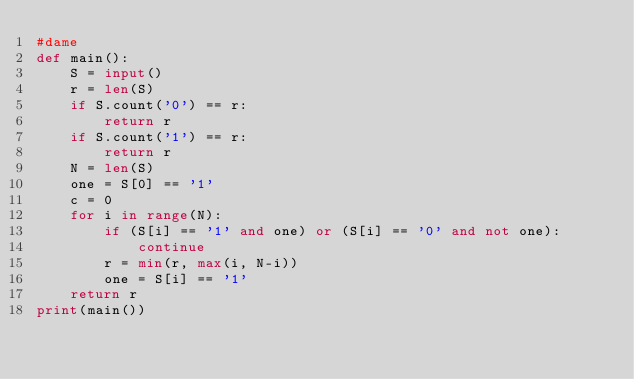<code> <loc_0><loc_0><loc_500><loc_500><_Python_>#dame 
def main():
    S = input()
    r = len(S)
    if S.count('0') == r:
        return r
    if S.count('1') == r:
        return r
    N = len(S)
    one = S[0] == '1'
    c = 0
    for i in range(N):
        if (S[i] == '1' and one) or (S[i] == '0' and not one):
            continue
        r = min(r, max(i, N-i))
        one = S[i] == '1'
    return r
print(main())
</code> 